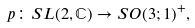<formula> <loc_0><loc_0><loc_500><loc_500>p \colon { S L } ( 2 , \mathbb { C } ) \to { S O } ( 3 ; 1 ) ^ { + } ,</formula> 